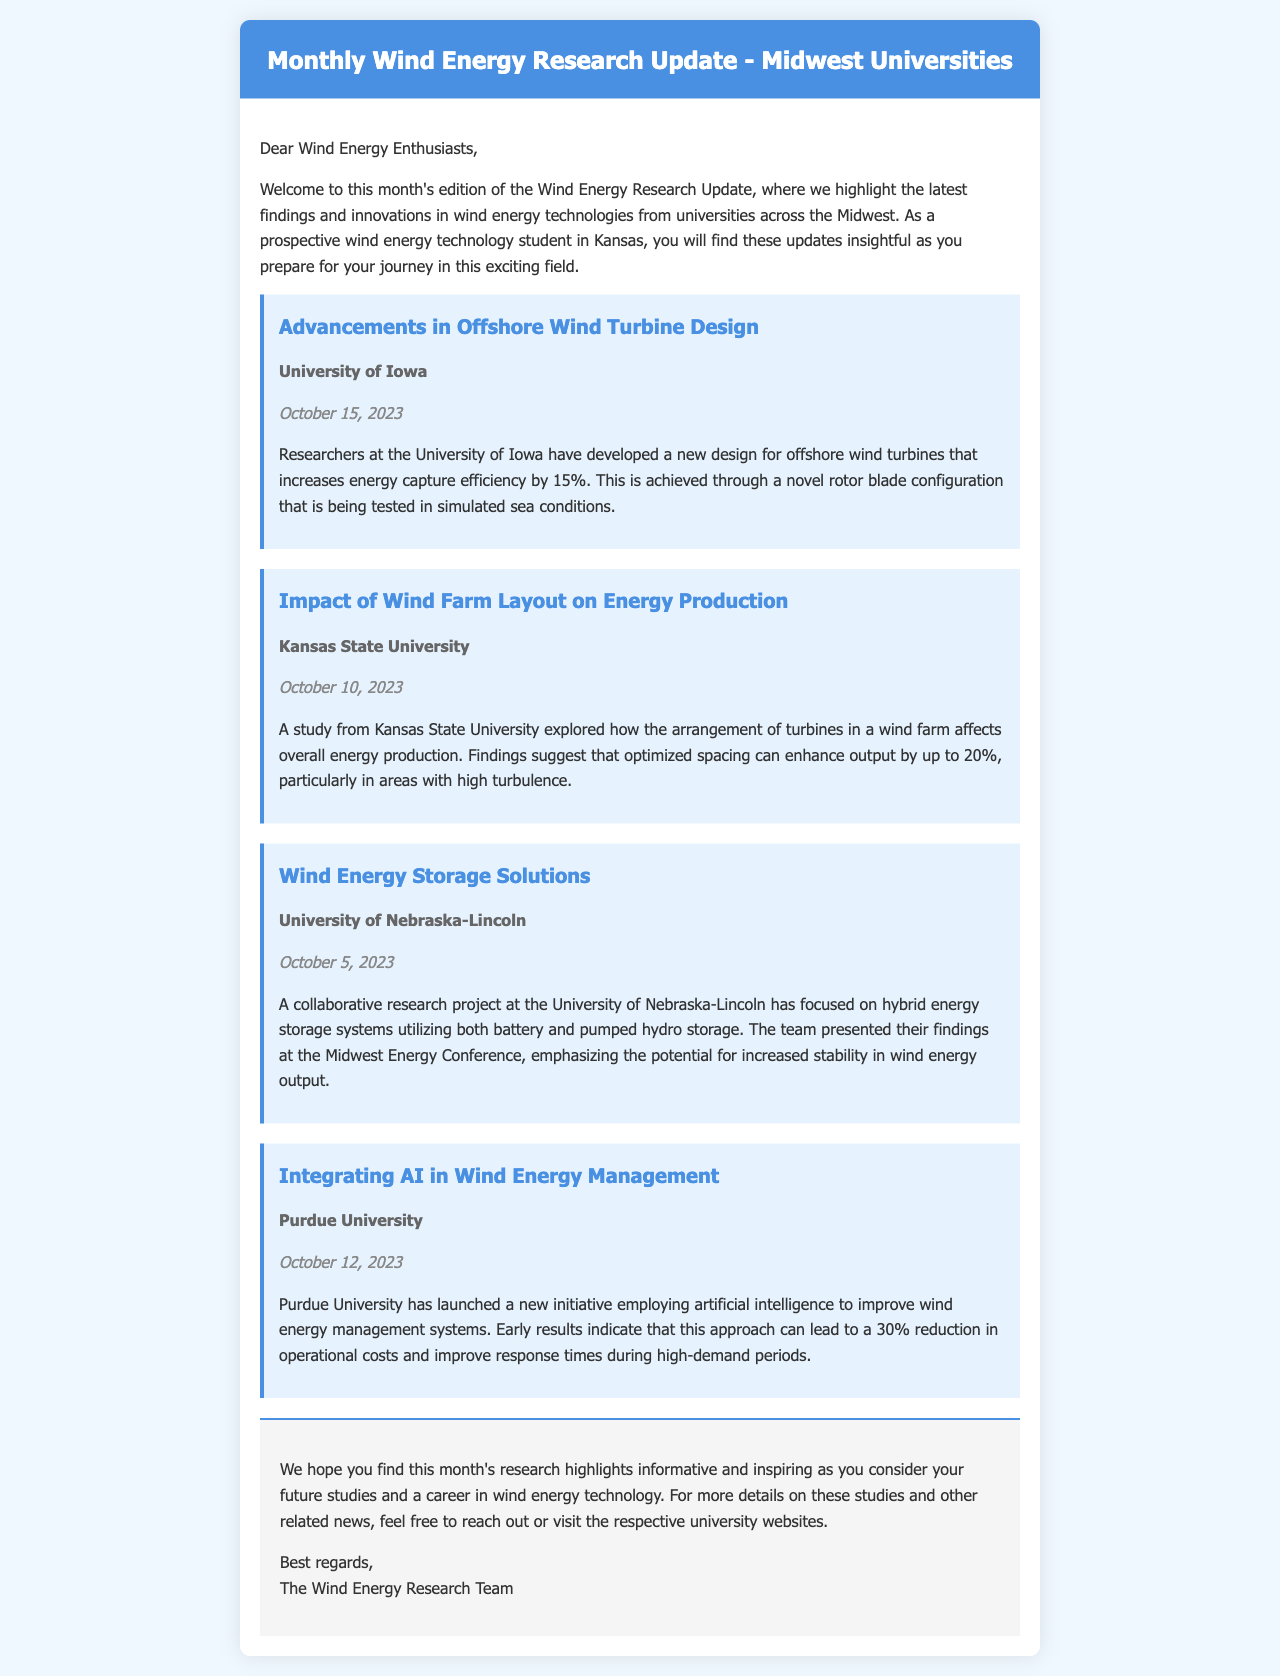What university conducted research on offshore wind turbine design? The document states that researchers at the University of Iowa developed a new design for offshore wind turbines.
Answer: University of Iowa What is the energy capture efficiency increase reported in the offshore wind turbine study? The document mentions that the new turbine design increases energy capture efficiency by 15%.
Answer: 15% What date was the research on wind farm layout published? According to the document, the study from Kansas State University was published on October 10, 2023.
Answer: October 10, 2023 What is the primary focus of the research project at the University of Nebraska-Lincoln? The document indicates that the collaborative research project focused on hybrid energy storage systems.
Answer: Hybrid energy storage systems Which university is utilizing artificial intelligence in wind energy management? The document states that Purdue University has launched an initiative employing artificial intelligence in wind energy management.
Answer: Purdue University What percentage reduction in operational costs is indicated by the AI approach? The document states that early results indicate a 30% reduction in operational costs due to the AI approach.
Answer: 30% What type of energy output stability is discussed in the research from the University of Nebraska-Lincoln? The document mentions that the team emphasized the potential for increased stability in wind energy output.
Answer: Increased stability Which research finding pertains to turbine spacing in wind farms? The findings from Kansas State University suggest that optimized spacing can enhance output by up to 20%.
Answer: Up to 20% How often is the Wind Energy Research Update published? The title and salutation of the document imply it is a monthly newsletter.
Answer: Monthly 